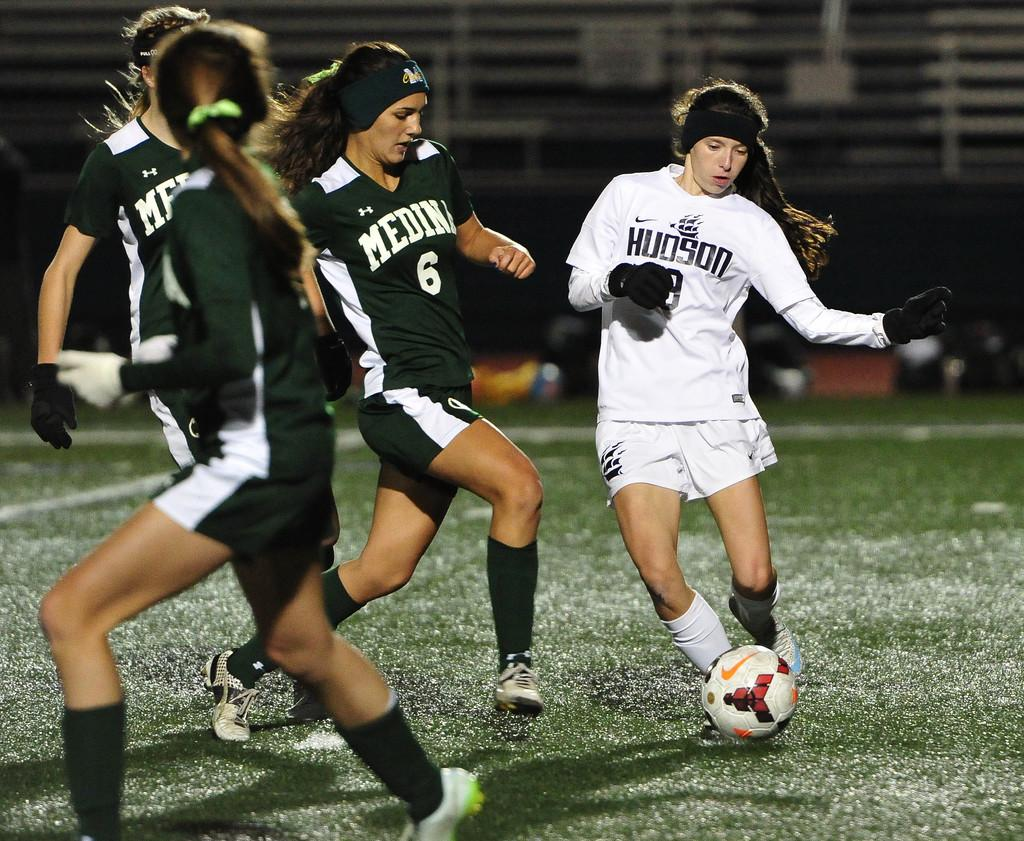How many people are in the image? There are four persons in the image. What activity are the persons engaged in? The persons are playing football. What type of surface is the football game being played on? The ground is covered with grass. What type of organization is responsible for maintaining the sea in the image? There is no sea present in the image, so it is not possible to determine which organization might be responsible for maintaining it. 